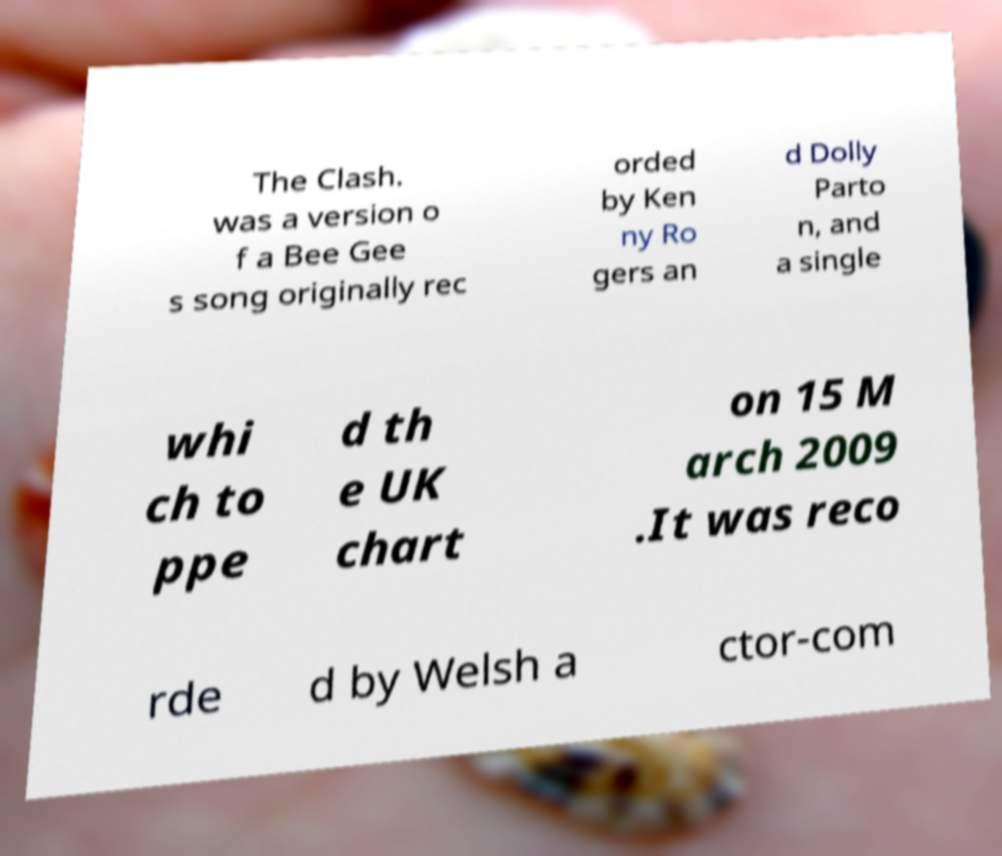What messages or text are displayed in this image? I need them in a readable, typed format. The Clash. was a version o f a Bee Gee s song originally rec orded by Ken ny Ro gers an d Dolly Parto n, and a single whi ch to ppe d th e UK chart on 15 M arch 2009 .It was reco rde d by Welsh a ctor-com 